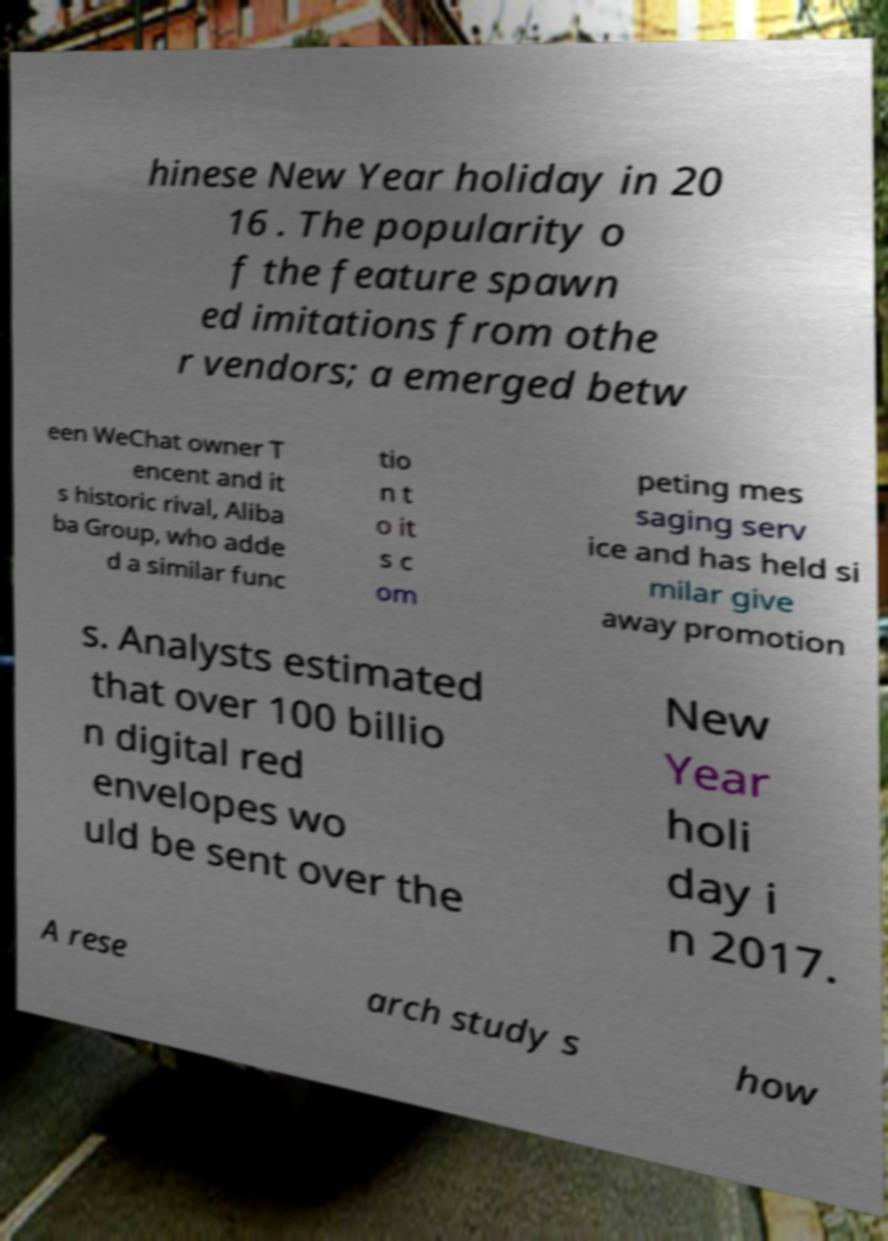Can you read and provide the text displayed in the image?This photo seems to have some interesting text. Can you extract and type it out for me? hinese New Year holiday in 20 16 . The popularity o f the feature spawn ed imitations from othe r vendors; a emerged betw een WeChat owner T encent and it s historic rival, Aliba ba Group, who adde d a similar func tio n t o it s c om peting mes saging serv ice and has held si milar give away promotion s. Analysts estimated that over 100 billio n digital red envelopes wo uld be sent over the New Year holi day i n 2017. A rese arch study s how 